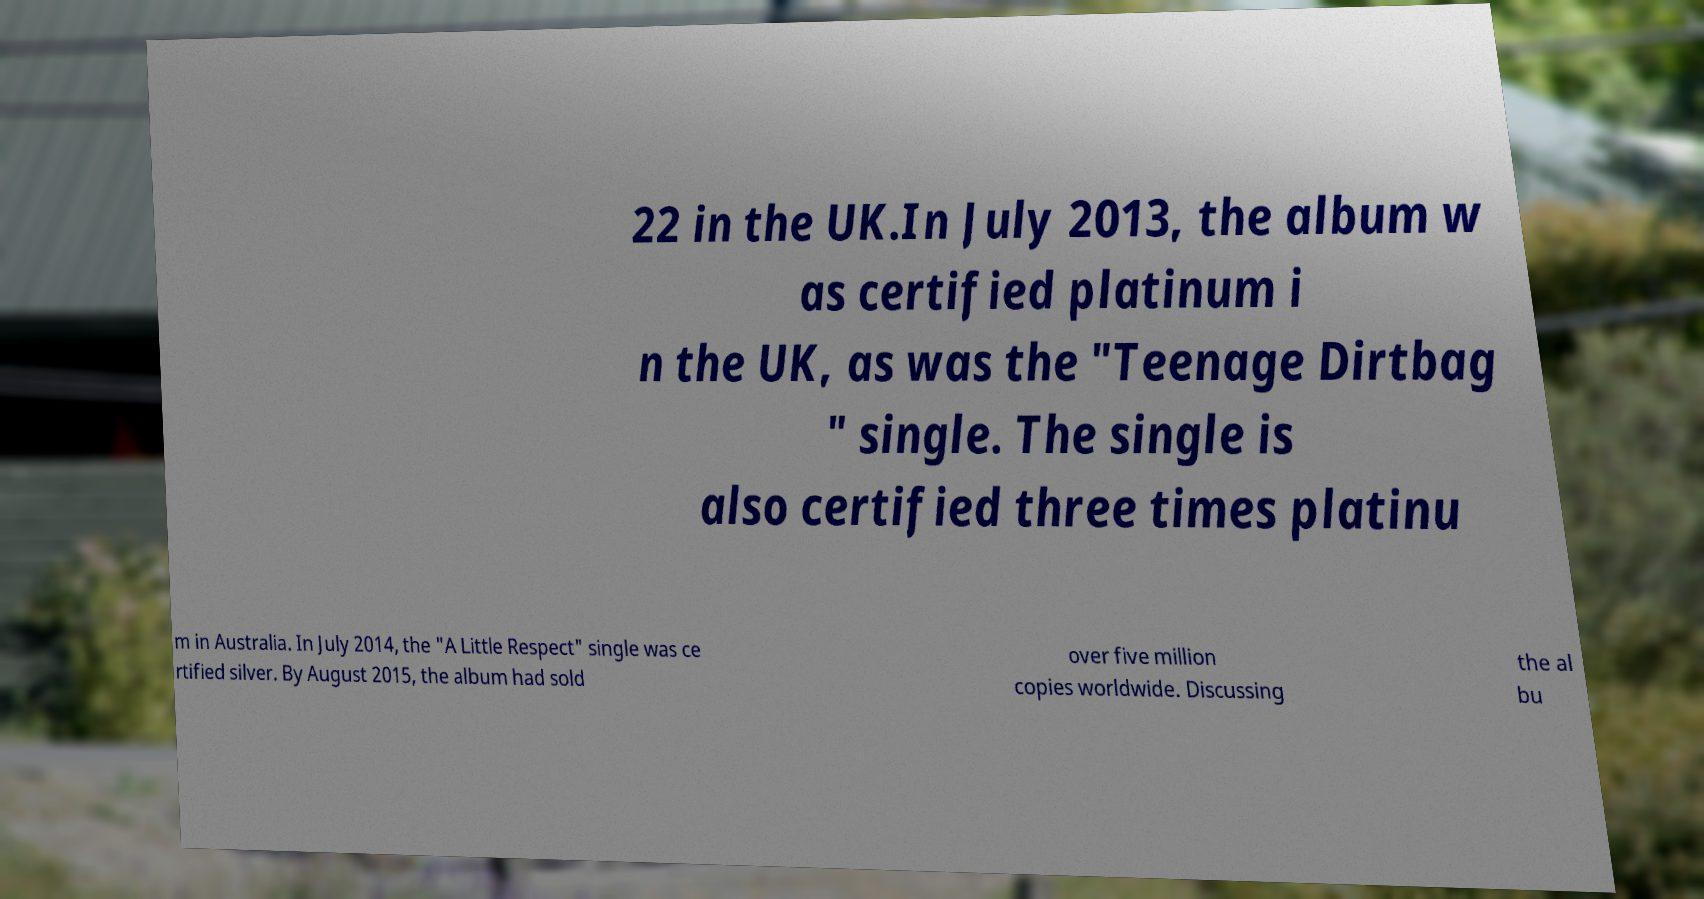I need the written content from this picture converted into text. Can you do that? 22 in the UK.In July 2013, the album w as certified platinum i n the UK, as was the "Teenage Dirtbag " single. The single is also certified three times platinu m in Australia. In July 2014, the "A Little Respect" single was ce rtified silver. By August 2015, the album had sold over five million copies worldwide. Discussing the al bu 